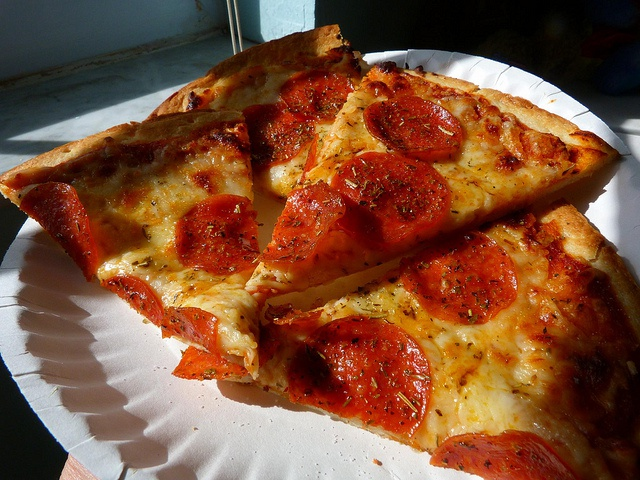Describe the objects in this image and their specific colors. I can see pizza in black, maroon, brown, and red tones, pizza in black, maroon, and red tones, and pizza in black, maroon, red, and tan tones in this image. 